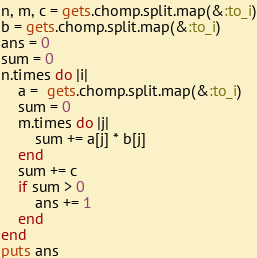<code> <loc_0><loc_0><loc_500><loc_500><_Ruby_>n, m, c = gets.chomp.split.map(&:to_i)
b = gets.chomp.split.map(&:to_i)
ans = 0
sum = 0
n.times do |i|
    a =  gets.chomp.split.map(&:to_i)
    sum = 0
    m.times do |j|
        sum += a[j] * b[j]
    end
    sum += c
    if sum > 0
        ans += 1
    end
end
puts ans</code> 